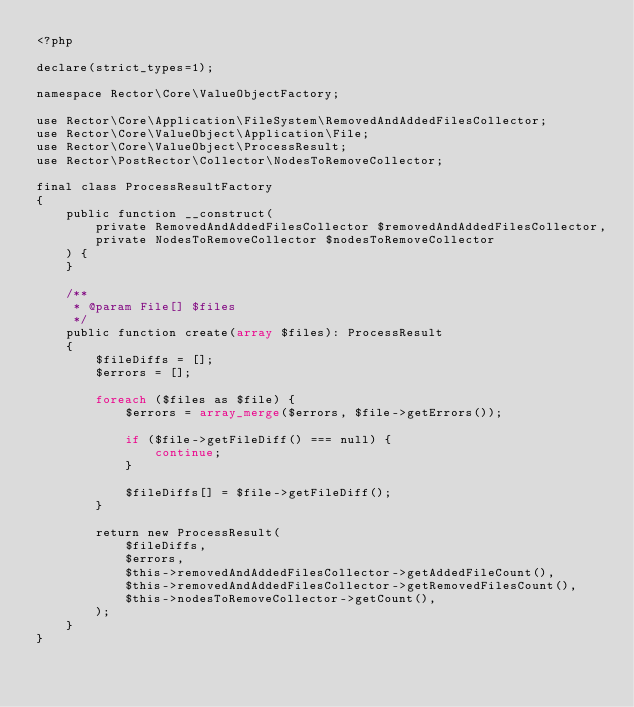<code> <loc_0><loc_0><loc_500><loc_500><_PHP_><?php

declare(strict_types=1);

namespace Rector\Core\ValueObjectFactory;

use Rector\Core\Application\FileSystem\RemovedAndAddedFilesCollector;
use Rector\Core\ValueObject\Application\File;
use Rector\Core\ValueObject\ProcessResult;
use Rector\PostRector\Collector\NodesToRemoveCollector;

final class ProcessResultFactory
{
    public function __construct(
        private RemovedAndAddedFilesCollector $removedAndAddedFilesCollector,
        private NodesToRemoveCollector $nodesToRemoveCollector
    ) {
    }

    /**
     * @param File[] $files
     */
    public function create(array $files): ProcessResult
    {
        $fileDiffs = [];
        $errors = [];

        foreach ($files as $file) {
            $errors = array_merge($errors, $file->getErrors());

            if ($file->getFileDiff() === null) {
                continue;
            }

            $fileDiffs[] = $file->getFileDiff();
        }

        return new ProcessResult(
            $fileDiffs,
            $errors,
            $this->removedAndAddedFilesCollector->getAddedFileCount(),
            $this->removedAndAddedFilesCollector->getRemovedFilesCount(),
            $this->nodesToRemoveCollector->getCount(),
        );
    }
}
</code> 